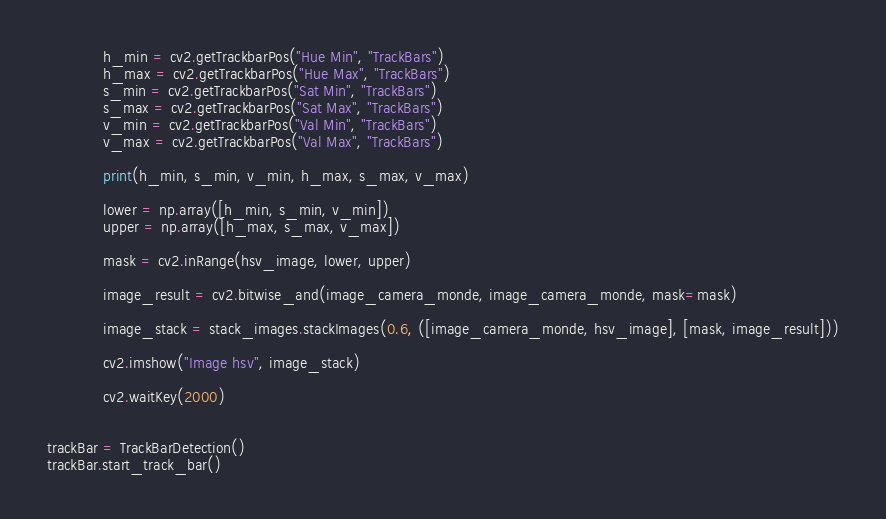<code> <loc_0><loc_0><loc_500><loc_500><_Python_>            h_min = cv2.getTrackbarPos("Hue Min", "TrackBars")
            h_max = cv2.getTrackbarPos("Hue Max", "TrackBars")
            s_min = cv2.getTrackbarPos("Sat Min", "TrackBars")
            s_max = cv2.getTrackbarPos("Sat Max", "TrackBars")
            v_min = cv2.getTrackbarPos("Val Min", "TrackBars")
            v_max = cv2.getTrackbarPos("Val Max", "TrackBars")

            print(h_min, s_min, v_min, h_max, s_max, v_max)

            lower = np.array([h_min, s_min, v_min])
            upper = np.array([h_max, s_max, v_max])

            mask = cv2.inRange(hsv_image, lower, upper)

            image_result = cv2.bitwise_and(image_camera_monde, image_camera_monde, mask=mask)

            image_stack = stack_images.stackImages(0.6, ([image_camera_monde, hsv_image], [mask, image_result]))

            cv2.imshow("Image hsv", image_stack)

            cv2.waitKey(2000)


trackBar = TrackBarDetection()
trackBar.start_track_bar()
</code> 